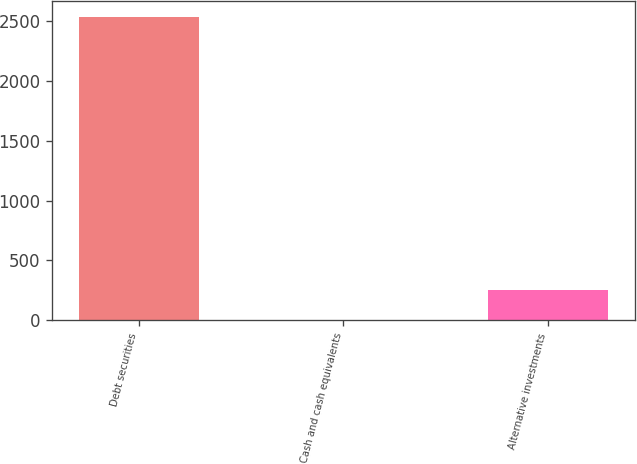<chart> <loc_0><loc_0><loc_500><loc_500><bar_chart><fcel>Debt securities<fcel>Cash and cash equivalents<fcel>Alternative investments<nl><fcel>2540<fcel>3<fcel>256.7<nl></chart> 